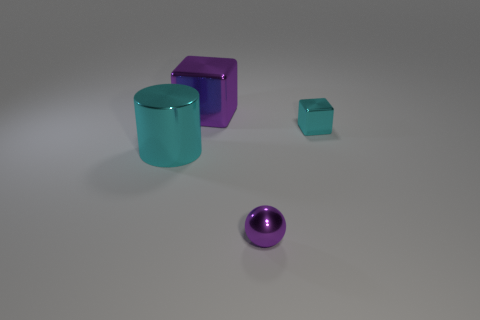Add 1 big purple matte cubes. How many objects exist? 5 Subtract all cylinders. How many objects are left? 3 Subtract 0 red blocks. How many objects are left? 4 Subtract all tiny metal spheres. Subtract all purple rubber cubes. How many objects are left? 3 Add 4 large shiny cylinders. How many large shiny cylinders are left? 5 Add 1 big brown matte blocks. How many big brown matte blocks exist? 1 